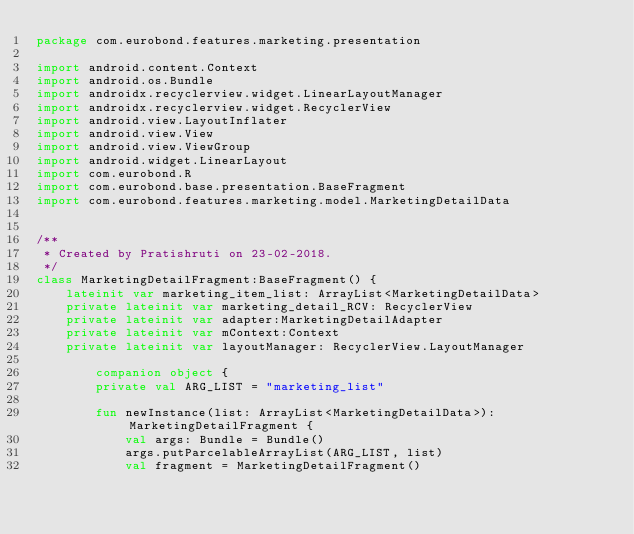Convert code to text. <code><loc_0><loc_0><loc_500><loc_500><_Kotlin_>package com.eurobond.features.marketing.presentation

import android.content.Context
import android.os.Bundle
import androidx.recyclerview.widget.LinearLayoutManager
import androidx.recyclerview.widget.RecyclerView
import android.view.LayoutInflater
import android.view.View
import android.view.ViewGroup
import android.widget.LinearLayout
import com.eurobond.R
import com.eurobond.base.presentation.BaseFragment
import com.eurobond.features.marketing.model.MarketingDetailData


/**
 * Created by Pratishruti on 23-02-2018.
 */
class MarketingDetailFragment:BaseFragment() {
    lateinit var marketing_item_list: ArrayList<MarketingDetailData>
    private lateinit var marketing_detail_RCV: RecyclerView
    private lateinit var adapter:MarketingDetailAdapter
    private lateinit var mContext:Context
    private lateinit var layoutManager: RecyclerView.LayoutManager

        companion object {
        private val ARG_LIST = "marketing_list"

        fun newInstance(list: ArrayList<MarketingDetailData>): MarketingDetailFragment {
            val args: Bundle = Bundle()
            args.putParcelableArrayList(ARG_LIST, list)
            val fragment = MarketingDetailFragment()</code> 